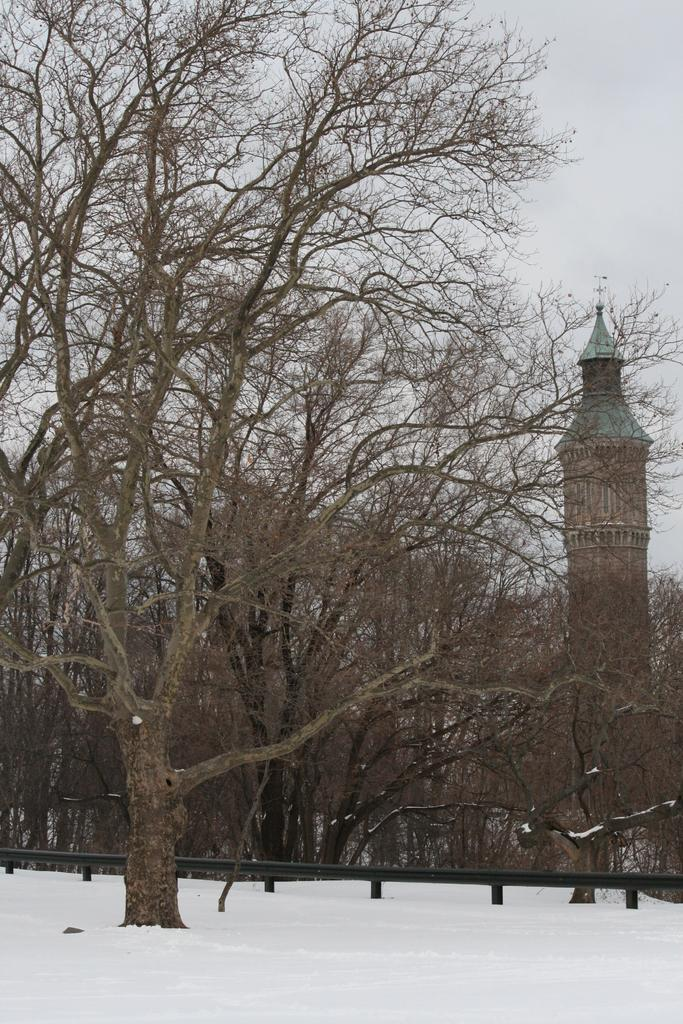What type of structures can be seen in the image? There are buildings in the image. What type of vegetation is present in the image? There are trees in the image. What weather condition is depicted in the image? There is snow visible in the image. What type of carriage can be seen in the image? There is no carriage present in the image. What type of brick is used to construct the buildings in the image? The provided facts do not mention the type of brick used to construct the buildings, and there is no indication of the building materials in the image. 